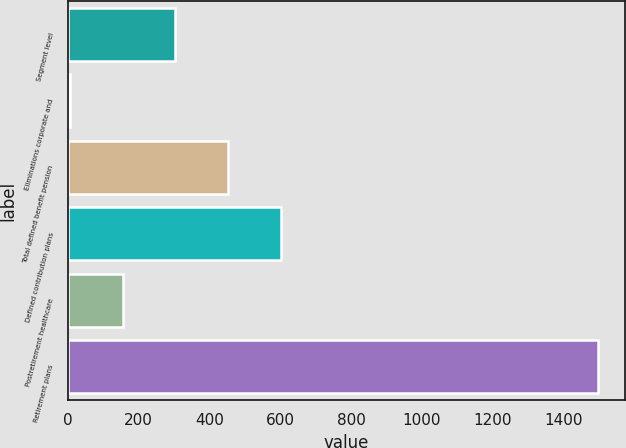Convert chart. <chart><loc_0><loc_0><loc_500><loc_500><bar_chart><fcel>Segment level<fcel>Eliminations corporate and<fcel>Total defined benefit pension<fcel>Defined contribution plans<fcel>Postretirement healthcare<fcel>Retirement plans<nl><fcel>303.6<fcel>5<fcel>452.9<fcel>602.2<fcel>154.3<fcel>1498<nl></chart> 